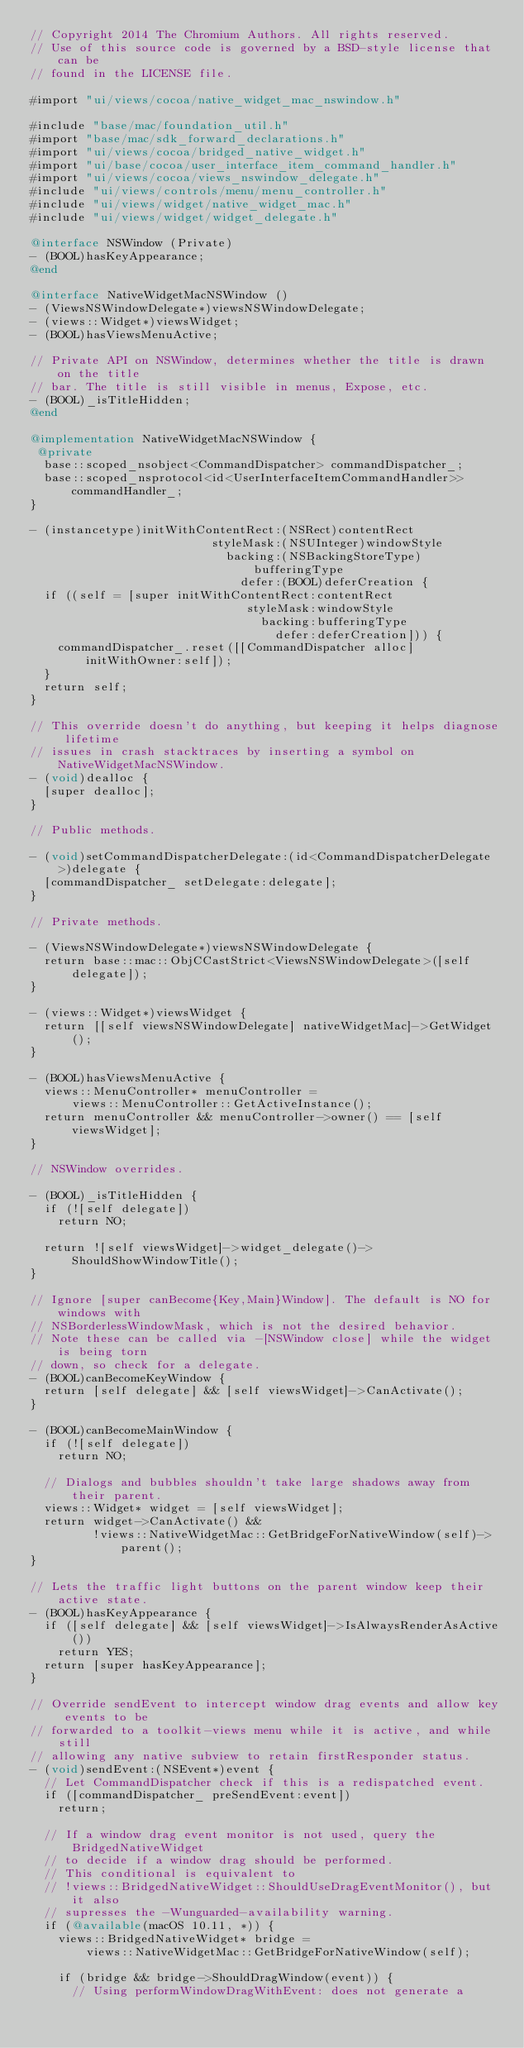Convert code to text. <code><loc_0><loc_0><loc_500><loc_500><_ObjectiveC_>// Copyright 2014 The Chromium Authors. All rights reserved.
// Use of this source code is governed by a BSD-style license that can be
// found in the LICENSE file.

#import "ui/views/cocoa/native_widget_mac_nswindow.h"

#include "base/mac/foundation_util.h"
#import "base/mac/sdk_forward_declarations.h"
#import "ui/views/cocoa/bridged_native_widget.h"
#import "ui/base/cocoa/user_interface_item_command_handler.h"
#import "ui/views/cocoa/views_nswindow_delegate.h"
#include "ui/views/controls/menu/menu_controller.h"
#include "ui/views/widget/native_widget_mac.h"
#include "ui/views/widget/widget_delegate.h"

@interface NSWindow (Private)
- (BOOL)hasKeyAppearance;
@end

@interface NativeWidgetMacNSWindow ()
- (ViewsNSWindowDelegate*)viewsNSWindowDelegate;
- (views::Widget*)viewsWidget;
- (BOOL)hasViewsMenuActive;

// Private API on NSWindow, determines whether the title is drawn on the title
// bar. The title is still visible in menus, Expose, etc.
- (BOOL)_isTitleHidden;
@end

@implementation NativeWidgetMacNSWindow {
 @private
  base::scoped_nsobject<CommandDispatcher> commandDispatcher_;
  base::scoped_nsprotocol<id<UserInterfaceItemCommandHandler>> commandHandler_;
}

- (instancetype)initWithContentRect:(NSRect)contentRect
                          styleMask:(NSUInteger)windowStyle
                            backing:(NSBackingStoreType)bufferingType
                              defer:(BOOL)deferCreation {
  if ((self = [super initWithContentRect:contentRect
                               styleMask:windowStyle
                                 backing:bufferingType
                                   defer:deferCreation])) {
    commandDispatcher_.reset([[CommandDispatcher alloc] initWithOwner:self]);
  }
  return self;
}

// This override doesn't do anything, but keeping it helps diagnose lifetime
// issues in crash stacktraces by inserting a symbol on NativeWidgetMacNSWindow.
- (void)dealloc {
  [super dealloc];
}

// Public methods.

- (void)setCommandDispatcherDelegate:(id<CommandDispatcherDelegate>)delegate {
  [commandDispatcher_ setDelegate:delegate];
}

// Private methods.

- (ViewsNSWindowDelegate*)viewsNSWindowDelegate {
  return base::mac::ObjCCastStrict<ViewsNSWindowDelegate>([self delegate]);
}

- (views::Widget*)viewsWidget {
  return [[self viewsNSWindowDelegate] nativeWidgetMac]->GetWidget();
}

- (BOOL)hasViewsMenuActive {
  views::MenuController* menuController =
      views::MenuController::GetActiveInstance();
  return menuController && menuController->owner() == [self viewsWidget];
}

// NSWindow overrides.

- (BOOL)_isTitleHidden {
  if (![self delegate])
    return NO;

  return ![self viewsWidget]->widget_delegate()->ShouldShowWindowTitle();
}

// Ignore [super canBecome{Key,Main}Window]. The default is NO for windows with
// NSBorderlessWindowMask, which is not the desired behavior.
// Note these can be called via -[NSWindow close] while the widget is being torn
// down, so check for a delegate.
- (BOOL)canBecomeKeyWindow {
  return [self delegate] && [self viewsWidget]->CanActivate();
}

- (BOOL)canBecomeMainWindow {
  if (![self delegate])
    return NO;

  // Dialogs and bubbles shouldn't take large shadows away from their parent.
  views::Widget* widget = [self viewsWidget];
  return widget->CanActivate() &&
         !views::NativeWidgetMac::GetBridgeForNativeWindow(self)->parent();
}

// Lets the traffic light buttons on the parent window keep their active state.
- (BOOL)hasKeyAppearance {
  if ([self delegate] && [self viewsWidget]->IsAlwaysRenderAsActive())
    return YES;
  return [super hasKeyAppearance];
}

// Override sendEvent to intercept window drag events and allow key events to be
// forwarded to a toolkit-views menu while it is active, and while still
// allowing any native subview to retain firstResponder status.
- (void)sendEvent:(NSEvent*)event {
  // Let CommandDispatcher check if this is a redispatched event.
  if ([commandDispatcher_ preSendEvent:event])
    return;

  // If a window drag event monitor is not used, query the BridgedNativeWidget
  // to decide if a window drag should be performed.
  // This conditional is equivalent to
  // !views::BridgedNativeWidget::ShouldUseDragEventMonitor(), but it also
  // supresses the -Wunguarded-availability warning.
  if (@available(macOS 10.11, *)) {
    views::BridgedNativeWidget* bridge =
        views::NativeWidgetMac::GetBridgeForNativeWindow(self);

    if (bridge && bridge->ShouldDragWindow(event)) {
      // Using performWindowDragWithEvent: does not generate a</code> 